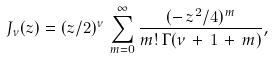Convert formula to latex. <formula><loc_0><loc_0><loc_500><loc_500>J _ { \nu } ( z ) = ( z / 2 ) ^ { \nu } \, \sum _ { m = 0 } ^ { \infty } \frac { ( - \, z ^ { 2 } / 4 ) ^ { m } } { m ! \, \Gamma ( \nu \, + \, 1 \, + \, m ) } ,</formula> 